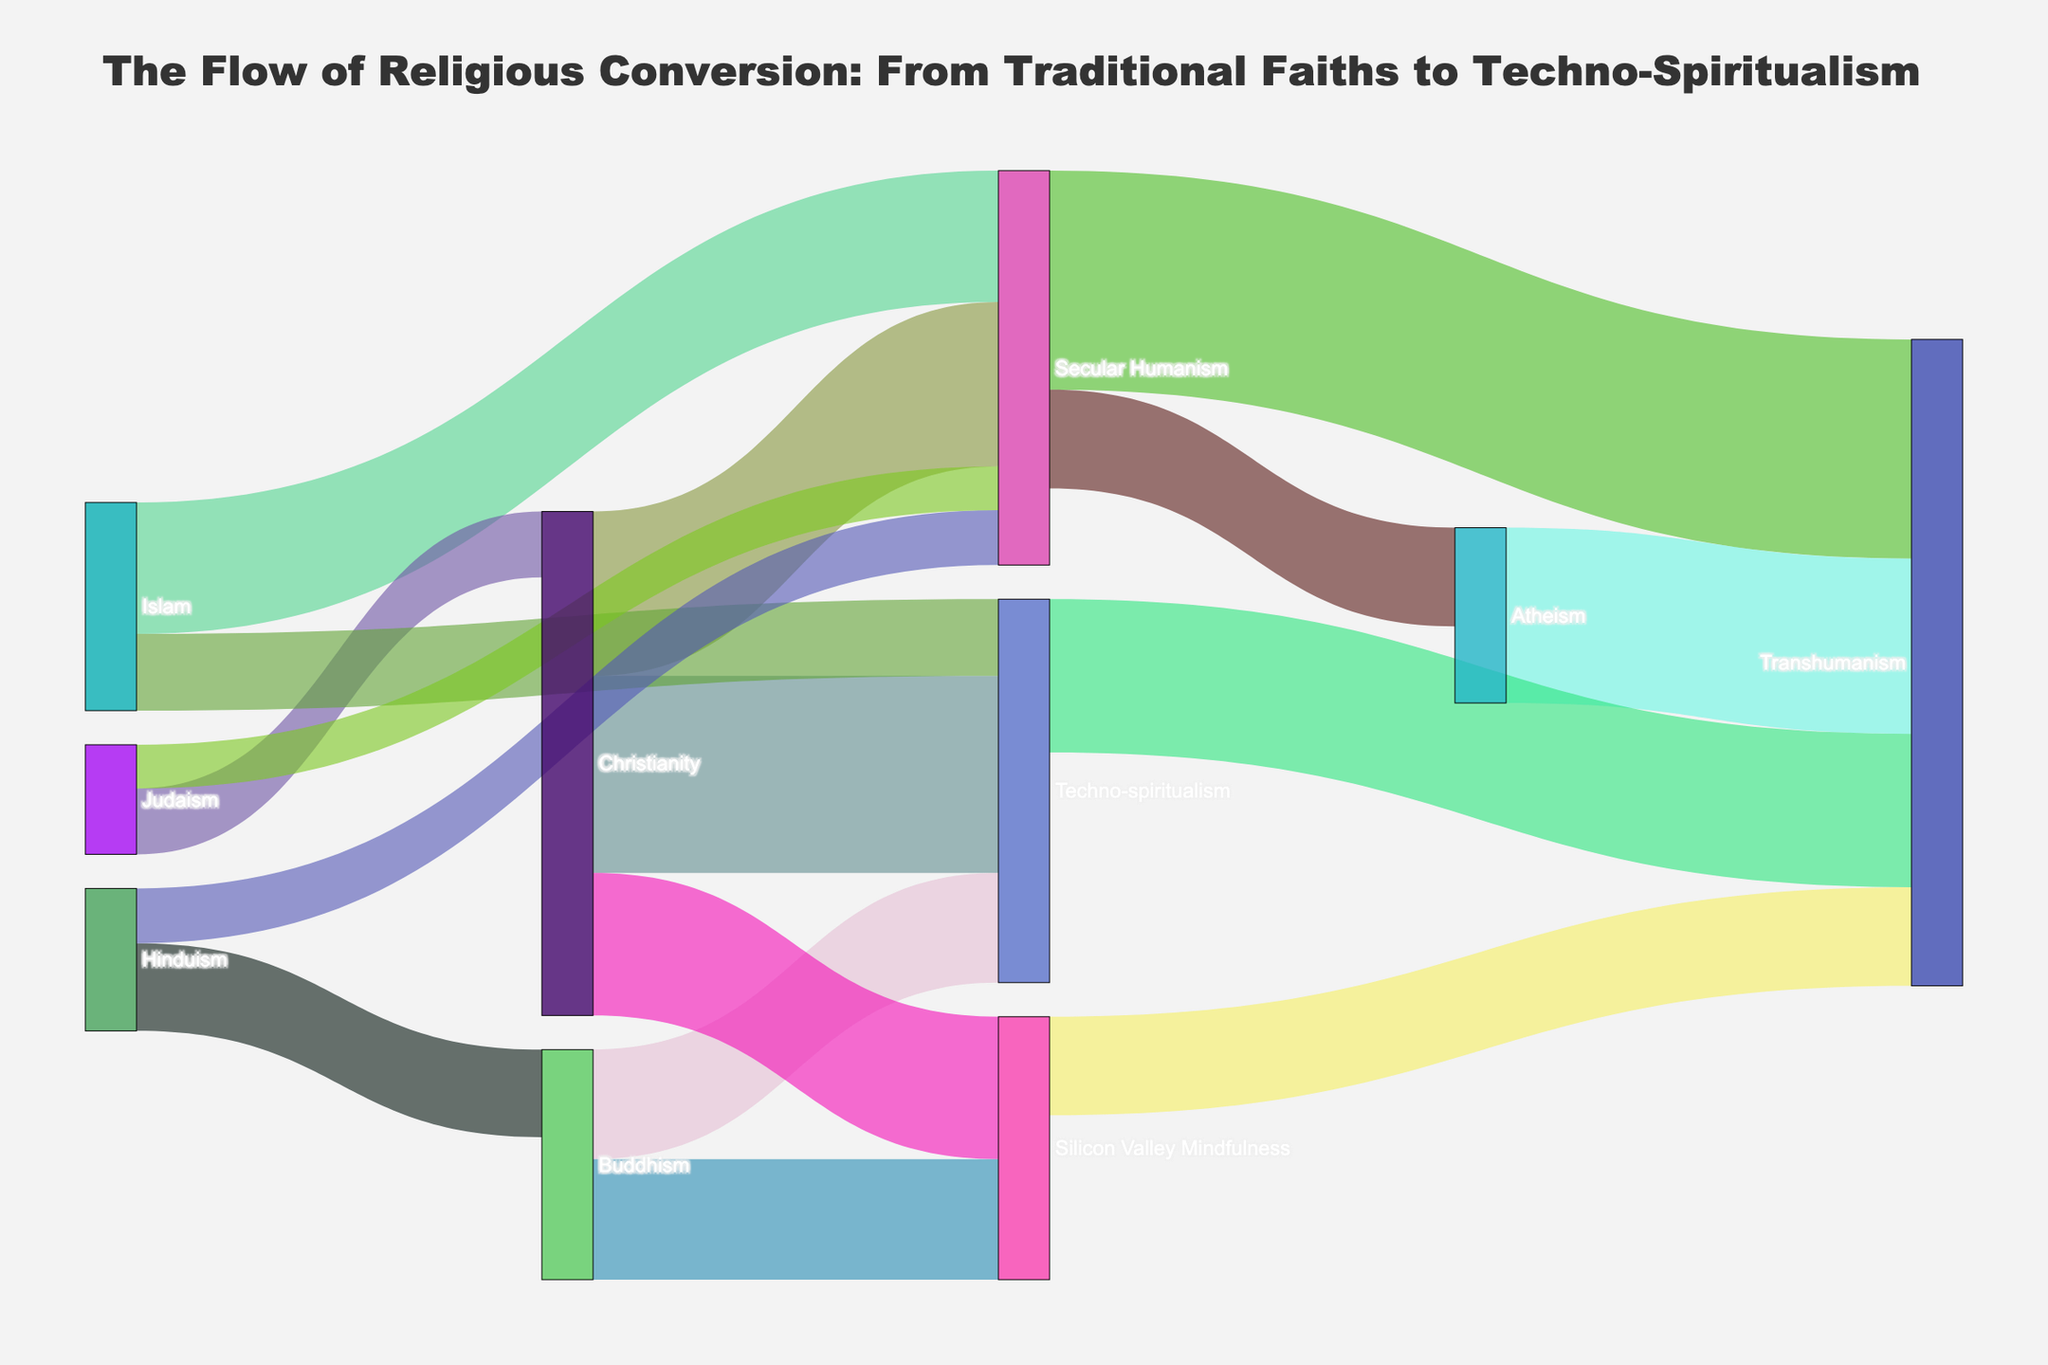Which religious group has the largest conversion to Secular Humanism? To determine this, look for the largest flow from any religious group to Secular Humanism. Christianity has a flow of 1500 to Secular Humanism, while Islam has 1200, and Hinduism and Judaism have 500 and 400 respectively. Therefore, Christianity has the largest conversion to Secular Humanism.
Answer: Christianity Which belief system has the highest total inflow in the diagram? To find this, sum all incoming flows to each belief system. Transhumanism has inflows from Secular Humanism (2000), Atheism (1600), Techno-spiritualism (1400), and Silicon Valley Mindfulness (900), totaling 5900. Other belief systems have lower totals.
Answer: Transhumanism What is the total flow from Christianity to technology-related belief systems (Techno-spiritualism and Silicon Valley Mindfulness)? Sum the conversion values from Christianity to Techno-spiritualism and Christianity to Silicon Valley Mindfulness. These values are 1800 and 1300 respectively, giving a total of 1800 + 1300 = 3100.
Answer: 3100 Which faith has the smallest conversion into Techno-spiritualism? By comparing the flows into Techno-spiritualism, Buddhism contributes 1000, Christianity 1800, and Islam 700. Thus, Islam has the smallest conversion into Techno-spiritualism.
Answer: Islam How does the conversion from Buddhism to Silicon Valley Mindfulness compare to that from Christianity to Silicon Valley Mindfulness? Examine the two flows: Buddhism to Silicon Valley Mindfulness is 1100, whereas Christianity to Silicon Valley Mindfulness is 1300. Therefore, Christianity has a greater conversion to Silicon Valley Mindfulness.
Answer: Christianity to Silicon Valley Mindfulness is greater What is the combined flow from all traditional faiths (Christianity, Islam, Hinduism, Judaism) to Secular Humanism? Add the conversion values from Christianity (1500), Islam (1200), Hinduism (500), and Judaism (400) to Secular Humanism. The total is 1500 + 1200 + 500 + 400 = 3600.
Answer: 3600 What is the difference in conversions to Techno-spiritualism between Christianity and Buddhism? Christianity converts 1800 individuals to Techno-spiritualism, while Buddhism converts 1000. The difference is 1800 - 1000 = 800.
Answer: 800 Which conversion flow specifically moves from a technology-related belief system back to a traditional faith? By examining flows, there are no direct conversions from technology-related belief systems (like Transhumanism, Techno-spiritualism, Silicon Valley Mindfulness) back to traditional faiths in the provided data.
Answer: None 